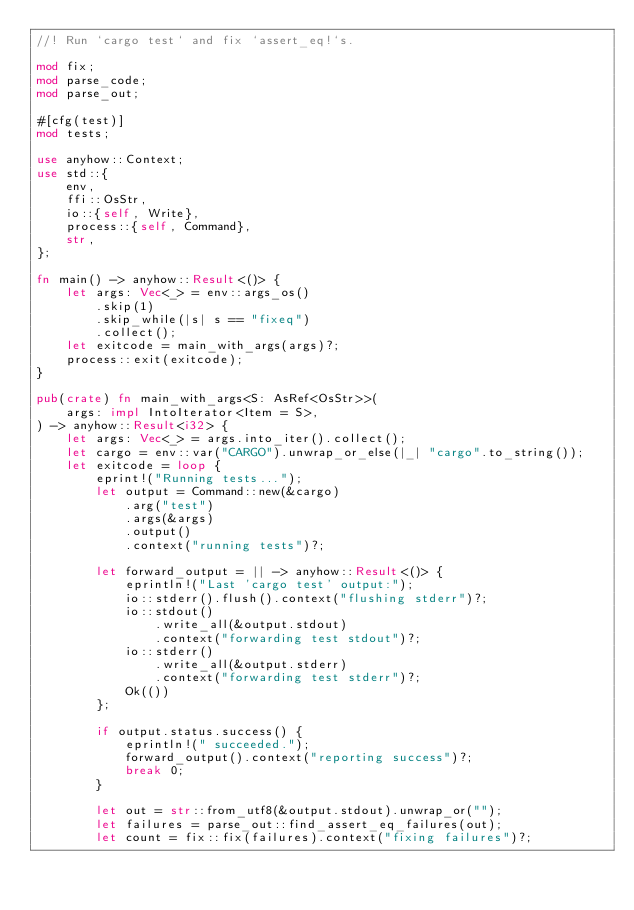Convert code to text. <code><loc_0><loc_0><loc_500><loc_500><_Rust_>//! Run `cargo test` and fix `assert_eq!`s.

mod fix;
mod parse_code;
mod parse_out;

#[cfg(test)]
mod tests;

use anyhow::Context;
use std::{
    env,
    ffi::OsStr,
    io::{self, Write},
    process::{self, Command},
    str,
};

fn main() -> anyhow::Result<()> {
    let args: Vec<_> = env::args_os()
        .skip(1)
        .skip_while(|s| s == "fixeq")
        .collect();
    let exitcode = main_with_args(args)?;
    process::exit(exitcode);
}

pub(crate) fn main_with_args<S: AsRef<OsStr>>(
    args: impl IntoIterator<Item = S>,
) -> anyhow::Result<i32> {
    let args: Vec<_> = args.into_iter().collect();
    let cargo = env::var("CARGO").unwrap_or_else(|_| "cargo".to_string());
    let exitcode = loop {
        eprint!("Running tests...");
        let output = Command::new(&cargo)
            .arg("test")
            .args(&args)
            .output()
            .context("running tests")?;

        let forward_output = || -> anyhow::Result<()> {
            eprintln!("Last 'cargo test' output:");
            io::stderr().flush().context("flushing stderr")?;
            io::stdout()
                .write_all(&output.stdout)
                .context("forwarding test stdout")?;
            io::stderr()
                .write_all(&output.stderr)
                .context("forwarding test stderr")?;
            Ok(())
        };

        if output.status.success() {
            eprintln!(" succeeded.");
            forward_output().context("reporting success")?;
            break 0;
        }

        let out = str::from_utf8(&output.stdout).unwrap_or("");
        let failures = parse_out::find_assert_eq_failures(out);
        let count = fix::fix(failures).context("fixing failures")?;
</code> 